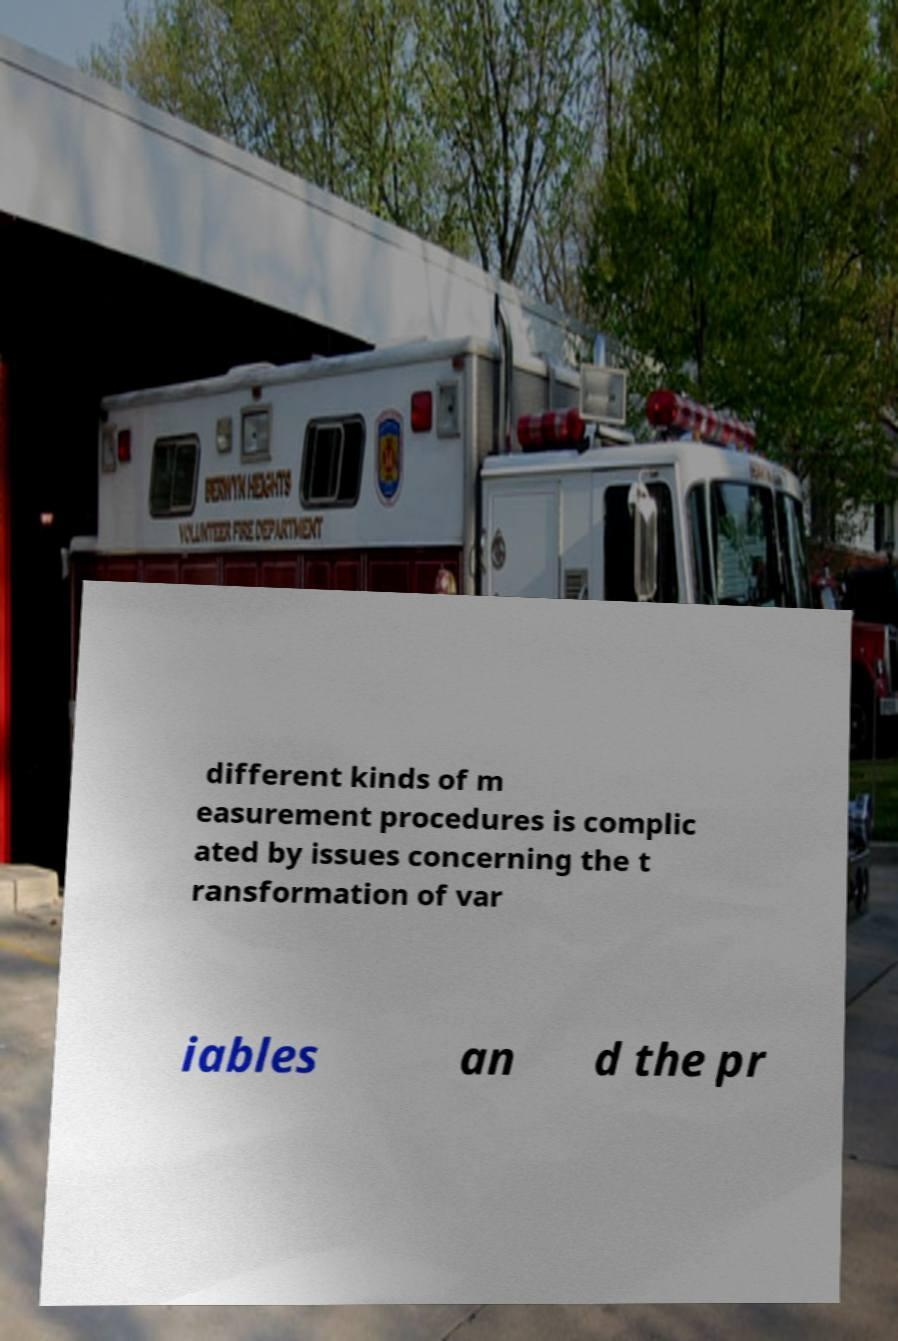For documentation purposes, I need the text within this image transcribed. Could you provide that? different kinds of m easurement procedures is complic ated by issues concerning the t ransformation of var iables an d the pr 